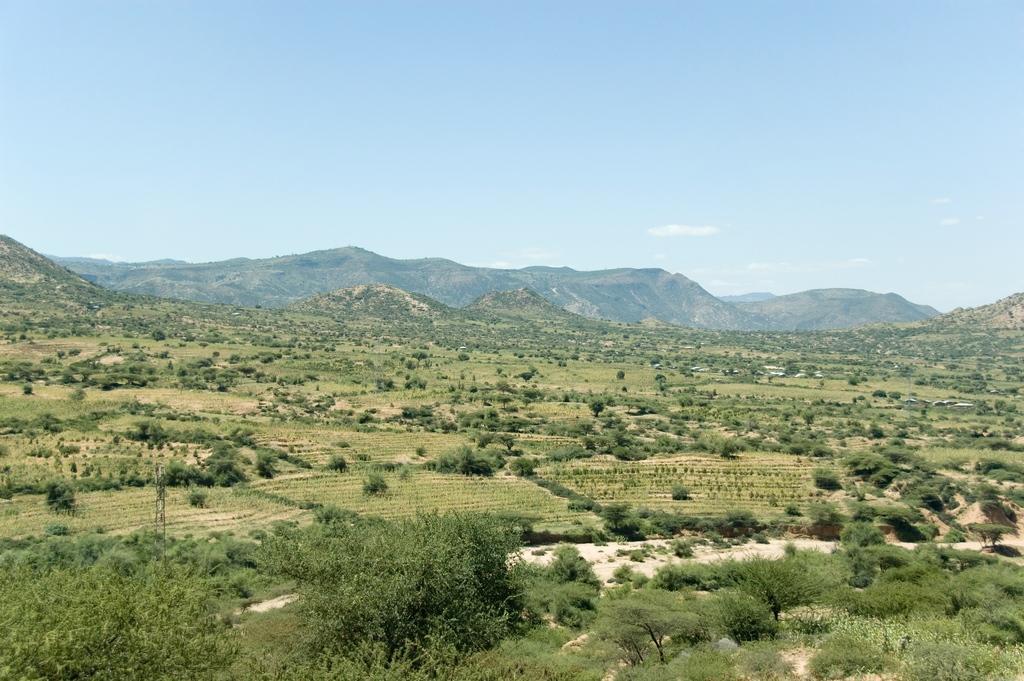How would you summarize this image in a sentence or two? In this picture we can see a land of trees, fields and path and in the background we can see mountains and above the mountains we have sky with clouds. 